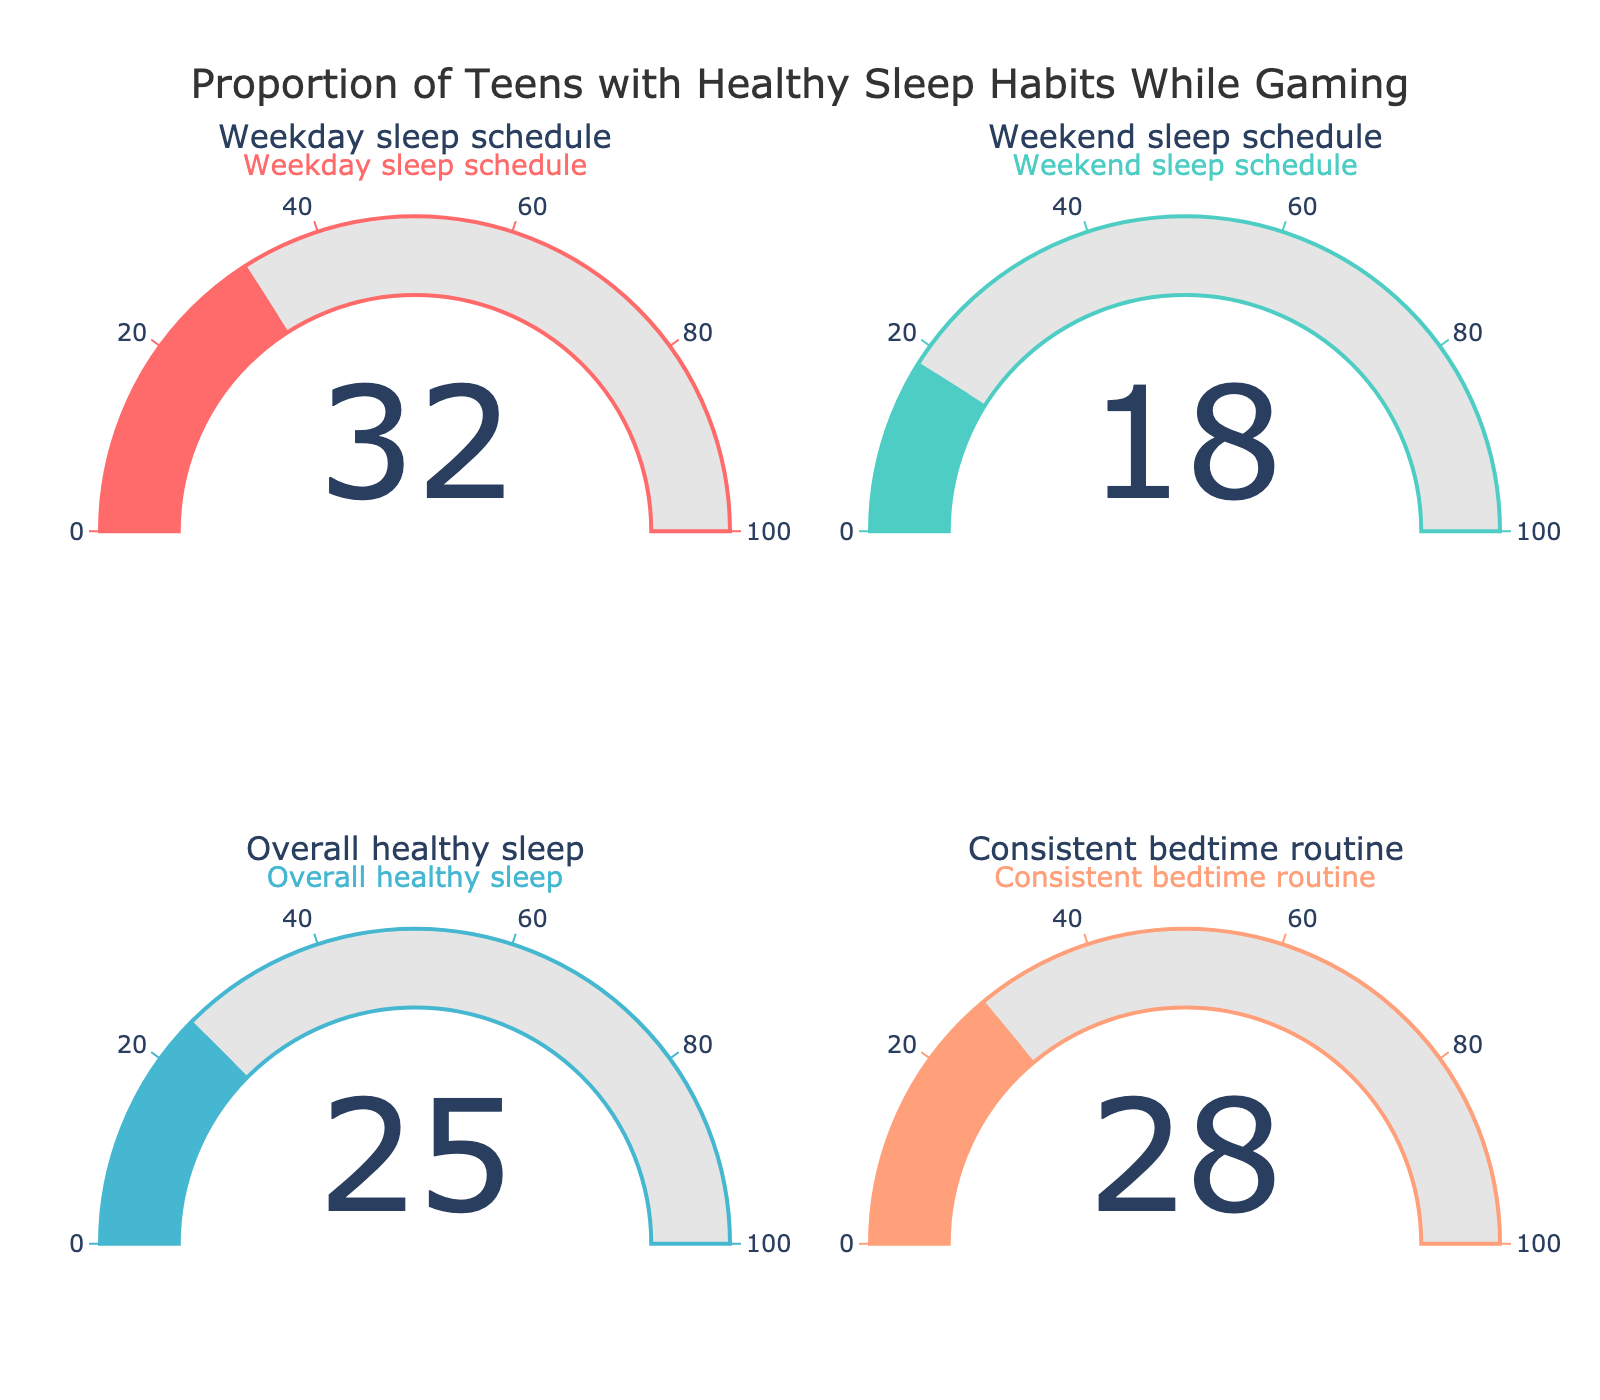What's the proportion of teens who maintain an overall healthy sleep while gaming regularly? The category labeled "Overall healthy sleep" shows a gauge indicating a percentage. The value displayed on this gauge represents the proportion.
Answer: 25% Which sleep category has the highest percentage of teens maintaining a healthy sleep schedule while gaming? By comparing the four gauges, the one labeled "Weekday sleep schedule" has the highest percentage.
Answer: Weekday sleep schedule Which sleep category has the lowest percentage of teens maintaining a healthy sleep schedule? Comparing the values on the gauges, the one labeled "Weekend sleep schedule" indicates the lowest percentage.
Answer: Weekend sleep schedule What is the combined percentage of teens maintaining a healthy sleep schedule on weekdays and weekends? Add the percentages shown in the "Weekday sleep schedule" and "Weekend sleep schedule" gauges: 32% + 18% equals 50%.
Answer: 50% How does the percentage for a consistent bedtime routine compare to the overall healthy sleep percentage? The gauge for "Consistent bedtime routine" shows 28%, while the "Overall healthy sleep" gauge indicates 25%. The former is 3 percentage points higher.
Answer: 3% higher What is the average percentage of all categories combined? Sum all the percentages and divide by the number of categories: (32% + 18% + 25% + 28%) / 4 = 25.75%.
Answer: 25.75% Which categories have a percentage lower than 30%? The gauges for "Weekend sleep schedule" (18%) and "Overall healthy sleep" (25%) both indicate percentages below 30%.
Answer: Weekend sleep schedule, Overall healthy sleep What is the percentage difference between teens maintaining a healthy sleep schedule on weekends versus weekdays? Subtract the "Weekend sleep schedule" percentage from the "Weekday sleep schedule" percentage: 32% - 18% equals 14%.
Answer: 14% How much more common is a consistent bedtime routine compared to maintaining a healthy sleep schedule overall? Subtract the "Overall healthy sleep" percentage (25%) from the "Consistent bedtime routine" percentage (28%): 28% - 25% equals 3%.
Answer: 3% Is the percentage of teens with a consistent bedtime routine higher or lower than the average percentage across all categories? The average percentage across all categories is 25.75%, and the percentage for a consistent bedtime routine is 28%, which is higher.
Answer: Higher 